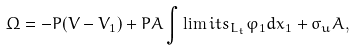Convert formula to latex. <formula><loc_0><loc_0><loc_500><loc_500>\Omega = - P ( V - V _ { 1 } ) + P A \int \lim i t s _ { L _ { t } } \varphi _ { 1 } d x _ { 1 } + \sigma _ { u } A ,</formula> 